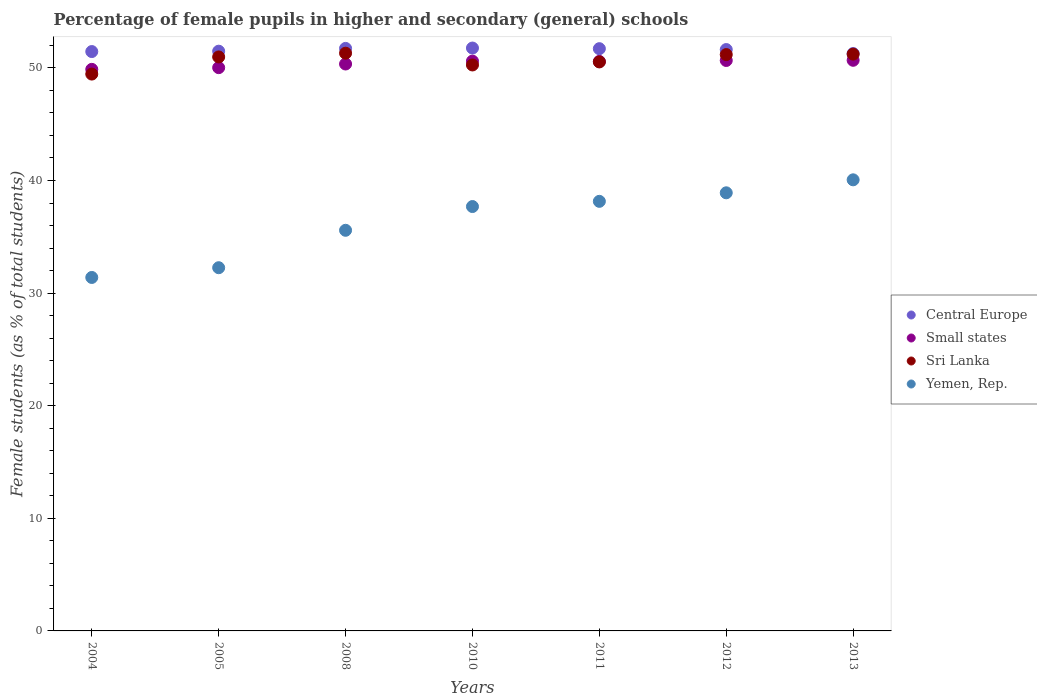What is the percentage of female pupils in higher and secondary schools in Yemen, Rep. in 2010?
Keep it short and to the point. 37.69. Across all years, what is the maximum percentage of female pupils in higher and secondary schools in Small states?
Keep it short and to the point. 50.67. Across all years, what is the minimum percentage of female pupils in higher and secondary schools in Sri Lanka?
Offer a terse response. 49.45. In which year was the percentage of female pupils in higher and secondary schools in Sri Lanka minimum?
Provide a succinct answer. 2004. What is the total percentage of female pupils in higher and secondary schools in Sri Lanka in the graph?
Keep it short and to the point. 354.91. What is the difference between the percentage of female pupils in higher and secondary schools in Sri Lanka in 2008 and that in 2012?
Make the answer very short. 0.12. What is the difference between the percentage of female pupils in higher and secondary schools in Sri Lanka in 2011 and the percentage of female pupils in higher and secondary schools in Central Europe in 2005?
Provide a succinct answer. -0.95. What is the average percentage of female pupils in higher and secondary schools in Central Europe per year?
Your answer should be compact. 51.57. In the year 2010, what is the difference between the percentage of female pupils in higher and secondary schools in Sri Lanka and percentage of female pupils in higher and secondary schools in Yemen, Rep.?
Ensure brevity in your answer.  12.57. What is the ratio of the percentage of female pupils in higher and secondary schools in Central Europe in 2010 to that in 2011?
Give a very brief answer. 1. Is the percentage of female pupils in higher and secondary schools in Small states in 2004 less than that in 2012?
Offer a terse response. Yes. Is the difference between the percentage of female pupils in higher and secondary schools in Sri Lanka in 2011 and 2012 greater than the difference between the percentage of female pupils in higher and secondary schools in Yemen, Rep. in 2011 and 2012?
Keep it short and to the point. Yes. What is the difference between the highest and the second highest percentage of female pupils in higher and secondary schools in Sri Lanka?
Your answer should be very brief. 0.08. What is the difference between the highest and the lowest percentage of female pupils in higher and secondary schools in Sri Lanka?
Offer a terse response. 1.85. In how many years, is the percentage of female pupils in higher and secondary schools in Central Europe greater than the average percentage of female pupils in higher and secondary schools in Central Europe taken over all years?
Offer a terse response. 4. Is it the case that in every year, the sum of the percentage of female pupils in higher and secondary schools in Small states and percentage of female pupils in higher and secondary schools in Central Europe  is greater than the sum of percentage of female pupils in higher and secondary schools in Sri Lanka and percentage of female pupils in higher and secondary schools in Yemen, Rep.?
Make the answer very short. Yes. Is the percentage of female pupils in higher and secondary schools in Yemen, Rep. strictly less than the percentage of female pupils in higher and secondary schools in Central Europe over the years?
Offer a very short reply. Yes. How many years are there in the graph?
Offer a terse response. 7. Does the graph contain any zero values?
Your answer should be very brief. No. Does the graph contain grids?
Offer a terse response. No. How many legend labels are there?
Provide a succinct answer. 4. What is the title of the graph?
Make the answer very short. Percentage of female pupils in higher and secondary (general) schools. What is the label or title of the Y-axis?
Offer a terse response. Female students (as % of total students). What is the Female students (as % of total students) in Central Europe in 2004?
Your answer should be very brief. 51.45. What is the Female students (as % of total students) of Small states in 2004?
Offer a very short reply. 49.87. What is the Female students (as % of total students) in Sri Lanka in 2004?
Offer a very short reply. 49.45. What is the Female students (as % of total students) of Yemen, Rep. in 2004?
Keep it short and to the point. 31.39. What is the Female students (as % of total students) in Central Europe in 2005?
Provide a short and direct response. 51.48. What is the Female students (as % of total students) in Small states in 2005?
Ensure brevity in your answer.  50.02. What is the Female students (as % of total students) of Sri Lanka in 2005?
Your answer should be compact. 50.97. What is the Female students (as % of total students) in Yemen, Rep. in 2005?
Your response must be concise. 32.25. What is the Female students (as % of total students) of Central Europe in 2008?
Your answer should be compact. 51.73. What is the Female students (as % of total students) in Small states in 2008?
Your answer should be very brief. 50.34. What is the Female students (as % of total students) of Sri Lanka in 2008?
Make the answer very short. 51.3. What is the Female students (as % of total students) of Yemen, Rep. in 2008?
Your response must be concise. 35.58. What is the Female students (as % of total students) of Central Europe in 2010?
Keep it short and to the point. 51.76. What is the Female students (as % of total students) in Small states in 2010?
Offer a very short reply. 50.6. What is the Female students (as % of total students) of Sri Lanka in 2010?
Ensure brevity in your answer.  50.26. What is the Female students (as % of total students) in Yemen, Rep. in 2010?
Offer a very short reply. 37.69. What is the Female students (as % of total students) of Central Europe in 2011?
Keep it short and to the point. 51.7. What is the Female students (as % of total students) of Small states in 2011?
Your answer should be compact. 50.57. What is the Female students (as % of total students) of Sri Lanka in 2011?
Provide a succinct answer. 50.53. What is the Female students (as % of total students) in Yemen, Rep. in 2011?
Your answer should be compact. 38.15. What is the Female students (as % of total students) of Central Europe in 2012?
Keep it short and to the point. 51.63. What is the Female students (as % of total students) of Small states in 2012?
Provide a short and direct response. 50.66. What is the Female students (as % of total students) in Sri Lanka in 2012?
Make the answer very short. 51.18. What is the Female students (as % of total students) in Yemen, Rep. in 2012?
Keep it short and to the point. 38.9. What is the Female students (as % of total students) of Central Europe in 2013?
Make the answer very short. 51.27. What is the Female students (as % of total students) in Small states in 2013?
Your answer should be very brief. 50.67. What is the Female students (as % of total students) of Sri Lanka in 2013?
Your answer should be very brief. 51.22. What is the Female students (as % of total students) in Yemen, Rep. in 2013?
Provide a short and direct response. 40.06. Across all years, what is the maximum Female students (as % of total students) of Central Europe?
Make the answer very short. 51.76. Across all years, what is the maximum Female students (as % of total students) in Small states?
Give a very brief answer. 50.67. Across all years, what is the maximum Female students (as % of total students) of Sri Lanka?
Keep it short and to the point. 51.3. Across all years, what is the maximum Female students (as % of total students) of Yemen, Rep.?
Offer a terse response. 40.06. Across all years, what is the minimum Female students (as % of total students) of Central Europe?
Your answer should be very brief. 51.27. Across all years, what is the minimum Female students (as % of total students) in Small states?
Offer a very short reply. 49.87. Across all years, what is the minimum Female students (as % of total students) in Sri Lanka?
Give a very brief answer. 49.45. Across all years, what is the minimum Female students (as % of total students) in Yemen, Rep.?
Ensure brevity in your answer.  31.39. What is the total Female students (as % of total students) in Central Europe in the graph?
Give a very brief answer. 361.02. What is the total Female students (as % of total students) in Small states in the graph?
Make the answer very short. 352.73. What is the total Female students (as % of total students) in Sri Lanka in the graph?
Keep it short and to the point. 354.91. What is the total Female students (as % of total students) of Yemen, Rep. in the graph?
Keep it short and to the point. 254.01. What is the difference between the Female students (as % of total students) of Central Europe in 2004 and that in 2005?
Ensure brevity in your answer.  -0.03. What is the difference between the Female students (as % of total students) of Small states in 2004 and that in 2005?
Your answer should be very brief. -0.15. What is the difference between the Female students (as % of total students) of Sri Lanka in 2004 and that in 2005?
Offer a terse response. -1.52. What is the difference between the Female students (as % of total students) of Yemen, Rep. in 2004 and that in 2005?
Provide a short and direct response. -0.86. What is the difference between the Female students (as % of total students) in Central Europe in 2004 and that in 2008?
Provide a short and direct response. -0.28. What is the difference between the Female students (as % of total students) in Small states in 2004 and that in 2008?
Your answer should be compact. -0.48. What is the difference between the Female students (as % of total students) of Sri Lanka in 2004 and that in 2008?
Your answer should be compact. -1.85. What is the difference between the Female students (as % of total students) in Yemen, Rep. in 2004 and that in 2008?
Your response must be concise. -4.19. What is the difference between the Female students (as % of total students) in Central Europe in 2004 and that in 2010?
Ensure brevity in your answer.  -0.31. What is the difference between the Female students (as % of total students) of Small states in 2004 and that in 2010?
Your response must be concise. -0.73. What is the difference between the Female students (as % of total students) of Sri Lanka in 2004 and that in 2010?
Give a very brief answer. -0.81. What is the difference between the Female students (as % of total students) in Yemen, Rep. in 2004 and that in 2010?
Your answer should be compact. -6.3. What is the difference between the Female students (as % of total students) in Central Europe in 2004 and that in 2011?
Make the answer very short. -0.26. What is the difference between the Female students (as % of total students) of Small states in 2004 and that in 2011?
Keep it short and to the point. -0.7. What is the difference between the Female students (as % of total students) in Sri Lanka in 2004 and that in 2011?
Provide a succinct answer. -1.08. What is the difference between the Female students (as % of total students) of Yemen, Rep. in 2004 and that in 2011?
Keep it short and to the point. -6.76. What is the difference between the Female students (as % of total students) in Central Europe in 2004 and that in 2012?
Ensure brevity in your answer.  -0.18. What is the difference between the Female students (as % of total students) in Small states in 2004 and that in 2012?
Keep it short and to the point. -0.79. What is the difference between the Female students (as % of total students) of Sri Lanka in 2004 and that in 2012?
Ensure brevity in your answer.  -1.73. What is the difference between the Female students (as % of total students) in Yemen, Rep. in 2004 and that in 2012?
Provide a succinct answer. -7.52. What is the difference between the Female students (as % of total students) of Central Europe in 2004 and that in 2013?
Provide a succinct answer. 0.18. What is the difference between the Female students (as % of total students) of Small states in 2004 and that in 2013?
Your response must be concise. -0.8. What is the difference between the Female students (as % of total students) of Sri Lanka in 2004 and that in 2013?
Provide a succinct answer. -1.77. What is the difference between the Female students (as % of total students) of Yemen, Rep. in 2004 and that in 2013?
Your answer should be compact. -8.67. What is the difference between the Female students (as % of total students) of Central Europe in 2005 and that in 2008?
Offer a terse response. -0.25. What is the difference between the Female students (as % of total students) of Small states in 2005 and that in 2008?
Provide a short and direct response. -0.32. What is the difference between the Female students (as % of total students) of Sri Lanka in 2005 and that in 2008?
Provide a short and direct response. -0.33. What is the difference between the Female students (as % of total students) in Yemen, Rep. in 2005 and that in 2008?
Offer a very short reply. -3.32. What is the difference between the Female students (as % of total students) in Central Europe in 2005 and that in 2010?
Your answer should be compact. -0.28. What is the difference between the Female students (as % of total students) of Small states in 2005 and that in 2010?
Give a very brief answer. -0.58. What is the difference between the Female students (as % of total students) of Sri Lanka in 2005 and that in 2010?
Make the answer very short. 0.71. What is the difference between the Female students (as % of total students) of Yemen, Rep. in 2005 and that in 2010?
Offer a terse response. -5.43. What is the difference between the Female students (as % of total students) in Central Europe in 2005 and that in 2011?
Your answer should be compact. -0.22. What is the difference between the Female students (as % of total students) in Small states in 2005 and that in 2011?
Your answer should be compact. -0.55. What is the difference between the Female students (as % of total students) of Sri Lanka in 2005 and that in 2011?
Your response must be concise. 0.44. What is the difference between the Female students (as % of total students) in Yemen, Rep. in 2005 and that in 2011?
Your response must be concise. -5.89. What is the difference between the Female students (as % of total students) of Central Europe in 2005 and that in 2012?
Offer a very short reply. -0.15. What is the difference between the Female students (as % of total students) in Small states in 2005 and that in 2012?
Your response must be concise. -0.64. What is the difference between the Female students (as % of total students) in Sri Lanka in 2005 and that in 2012?
Offer a terse response. -0.21. What is the difference between the Female students (as % of total students) of Yemen, Rep. in 2005 and that in 2012?
Your response must be concise. -6.65. What is the difference between the Female students (as % of total students) of Central Europe in 2005 and that in 2013?
Give a very brief answer. 0.21. What is the difference between the Female students (as % of total students) of Small states in 2005 and that in 2013?
Offer a very short reply. -0.65. What is the difference between the Female students (as % of total students) of Sri Lanka in 2005 and that in 2013?
Provide a short and direct response. -0.25. What is the difference between the Female students (as % of total students) of Yemen, Rep. in 2005 and that in 2013?
Provide a short and direct response. -7.8. What is the difference between the Female students (as % of total students) of Central Europe in 2008 and that in 2010?
Ensure brevity in your answer.  -0.03. What is the difference between the Female students (as % of total students) of Small states in 2008 and that in 2010?
Offer a terse response. -0.25. What is the difference between the Female students (as % of total students) in Sri Lanka in 2008 and that in 2010?
Your response must be concise. 1.05. What is the difference between the Female students (as % of total students) of Yemen, Rep. in 2008 and that in 2010?
Keep it short and to the point. -2.11. What is the difference between the Female students (as % of total students) of Central Europe in 2008 and that in 2011?
Provide a short and direct response. 0.02. What is the difference between the Female students (as % of total students) of Small states in 2008 and that in 2011?
Offer a terse response. -0.23. What is the difference between the Female students (as % of total students) in Sri Lanka in 2008 and that in 2011?
Offer a very short reply. 0.78. What is the difference between the Female students (as % of total students) of Yemen, Rep. in 2008 and that in 2011?
Your answer should be very brief. -2.57. What is the difference between the Female students (as % of total students) of Central Europe in 2008 and that in 2012?
Offer a terse response. 0.1. What is the difference between the Female students (as % of total students) of Small states in 2008 and that in 2012?
Your answer should be very brief. -0.31. What is the difference between the Female students (as % of total students) of Sri Lanka in 2008 and that in 2012?
Provide a short and direct response. 0.12. What is the difference between the Female students (as % of total students) of Yemen, Rep. in 2008 and that in 2012?
Ensure brevity in your answer.  -3.33. What is the difference between the Female students (as % of total students) of Central Europe in 2008 and that in 2013?
Provide a short and direct response. 0.46. What is the difference between the Female students (as % of total students) in Small states in 2008 and that in 2013?
Your answer should be compact. -0.33. What is the difference between the Female students (as % of total students) in Sri Lanka in 2008 and that in 2013?
Offer a very short reply. 0.08. What is the difference between the Female students (as % of total students) of Yemen, Rep. in 2008 and that in 2013?
Your response must be concise. -4.48. What is the difference between the Female students (as % of total students) of Central Europe in 2010 and that in 2011?
Keep it short and to the point. 0.06. What is the difference between the Female students (as % of total students) of Small states in 2010 and that in 2011?
Your answer should be very brief. 0.03. What is the difference between the Female students (as % of total students) in Sri Lanka in 2010 and that in 2011?
Offer a very short reply. -0.27. What is the difference between the Female students (as % of total students) of Yemen, Rep. in 2010 and that in 2011?
Your answer should be very brief. -0.46. What is the difference between the Female students (as % of total students) in Central Europe in 2010 and that in 2012?
Provide a succinct answer. 0.13. What is the difference between the Female students (as % of total students) of Small states in 2010 and that in 2012?
Offer a terse response. -0.06. What is the difference between the Female students (as % of total students) in Sri Lanka in 2010 and that in 2012?
Offer a terse response. -0.92. What is the difference between the Female students (as % of total students) of Yemen, Rep. in 2010 and that in 2012?
Offer a very short reply. -1.22. What is the difference between the Female students (as % of total students) in Central Europe in 2010 and that in 2013?
Offer a terse response. 0.49. What is the difference between the Female students (as % of total students) of Small states in 2010 and that in 2013?
Your answer should be very brief. -0.07. What is the difference between the Female students (as % of total students) in Sri Lanka in 2010 and that in 2013?
Provide a succinct answer. -0.96. What is the difference between the Female students (as % of total students) of Yemen, Rep. in 2010 and that in 2013?
Give a very brief answer. -2.37. What is the difference between the Female students (as % of total students) in Central Europe in 2011 and that in 2012?
Make the answer very short. 0.08. What is the difference between the Female students (as % of total students) in Small states in 2011 and that in 2012?
Offer a terse response. -0.08. What is the difference between the Female students (as % of total students) in Sri Lanka in 2011 and that in 2012?
Keep it short and to the point. -0.65. What is the difference between the Female students (as % of total students) of Yemen, Rep. in 2011 and that in 2012?
Your answer should be very brief. -0.76. What is the difference between the Female students (as % of total students) in Central Europe in 2011 and that in 2013?
Your response must be concise. 0.43. What is the difference between the Female students (as % of total students) in Small states in 2011 and that in 2013?
Keep it short and to the point. -0.1. What is the difference between the Female students (as % of total students) of Sri Lanka in 2011 and that in 2013?
Provide a succinct answer. -0.69. What is the difference between the Female students (as % of total students) in Yemen, Rep. in 2011 and that in 2013?
Offer a terse response. -1.91. What is the difference between the Female students (as % of total students) of Central Europe in 2012 and that in 2013?
Your answer should be compact. 0.35. What is the difference between the Female students (as % of total students) in Small states in 2012 and that in 2013?
Your answer should be compact. -0.02. What is the difference between the Female students (as % of total students) in Sri Lanka in 2012 and that in 2013?
Give a very brief answer. -0.04. What is the difference between the Female students (as % of total students) of Yemen, Rep. in 2012 and that in 2013?
Your response must be concise. -1.15. What is the difference between the Female students (as % of total students) in Central Europe in 2004 and the Female students (as % of total students) in Small states in 2005?
Your answer should be very brief. 1.43. What is the difference between the Female students (as % of total students) in Central Europe in 2004 and the Female students (as % of total students) in Sri Lanka in 2005?
Offer a terse response. 0.48. What is the difference between the Female students (as % of total students) of Central Europe in 2004 and the Female students (as % of total students) of Yemen, Rep. in 2005?
Offer a very short reply. 19.19. What is the difference between the Female students (as % of total students) in Small states in 2004 and the Female students (as % of total students) in Sri Lanka in 2005?
Offer a very short reply. -1.1. What is the difference between the Female students (as % of total students) of Small states in 2004 and the Female students (as % of total students) of Yemen, Rep. in 2005?
Give a very brief answer. 17.61. What is the difference between the Female students (as % of total students) of Sri Lanka in 2004 and the Female students (as % of total students) of Yemen, Rep. in 2005?
Your answer should be compact. 17.2. What is the difference between the Female students (as % of total students) of Central Europe in 2004 and the Female students (as % of total students) of Small states in 2008?
Provide a succinct answer. 1.1. What is the difference between the Female students (as % of total students) in Central Europe in 2004 and the Female students (as % of total students) in Sri Lanka in 2008?
Your answer should be compact. 0.14. What is the difference between the Female students (as % of total students) in Central Europe in 2004 and the Female students (as % of total students) in Yemen, Rep. in 2008?
Offer a very short reply. 15.87. What is the difference between the Female students (as % of total students) of Small states in 2004 and the Female students (as % of total students) of Sri Lanka in 2008?
Give a very brief answer. -1.44. What is the difference between the Female students (as % of total students) of Small states in 2004 and the Female students (as % of total students) of Yemen, Rep. in 2008?
Provide a succinct answer. 14.29. What is the difference between the Female students (as % of total students) in Sri Lanka in 2004 and the Female students (as % of total students) in Yemen, Rep. in 2008?
Give a very brief answer. 13.87. What is the difference between the Female students (as % of total students) of Central Europe in 2004 and the Female students (as % of total students) of Small states in 2010?
Keep it short and to the point. 0.85. What is the difference between the Female students (as % of total students) of Central Europe in 2004 and the Female students (as % of total students) of Sri Lanka in 2010?
Provide a succinct answer. 1.19. What is the difference between the Female students (as % of total students) in Central Europe in 2004 and the Female students (as % of total students) in Yemen, Rep. in 2010?
Provide a succinct answer. 13.76. What is the difference between the Female students (as % of total students) in Small states in 2004 and the Female students (as % of total students) in Sri Lanka in 2010?
Your answer should be very brief. -0.39. What is the difference between the Female students (as % of total students) of Small states in 2004 and the Female students (as % of total students) of Yemen, Rep. in 2010?
Make the answer very short. 12.18. What is the difference between the Female students (as % of total students) of Sri Lanka in 2004 and the Female students (as % of total students) of Yemen, Rep. in 2010?
Provide a succinct answer. 11.76. What is the difference between the Female students (as % of total students) in Central Europe in 2004 and the Female students (as % of total students) in Small states in 2011?
Offer a very short reply. 0.88. What is the difference between the Female students (as % of total students) in Central Europe in 2004 and the Female students (as % of total students) in Sri Lanka in 2011?
Offer a very short reply. 0.92. What is the difference between the Female students (as % of total students) of Central Europe in 2004 and the Female students (as % of total students) of Yemen, Rep. in 2011?
Your answer should be very brief. 13.3. What is the difference between the Female students (as % of total students) in Small states in 2004 and the Female students (as % of total students) in Sri Lanka in 2011?
Give a very brief answer. -0.66. What is the difference between the Female students (as % of total students) of Small states in 2004 and the Female students (as % of total students) of Yemen, Rep. in 2011?
Provide a succinct answer. 11.72. What is the difference between the Female students (as % of total students) in Sri Lanka in 2004 and the Female students (as % of total students) in Yemen, Rep. in 2011?
Provide a succinct answer. 11.3. What is the difference between the Female students (as % of total students) in Central Europe in 2004 and the Female students (as % of total students) in Small states in 2012?
Provide a short and direct response. 0.79. What is the difference between the Female students (as % of total students) of Central Europe in 2004 and the Female students (as % of total students) of Sri Lanka in 2012?
Keep it short and to the point. 0.27. What is the difference between the Female students (as % of total students) in Central Europe in 2004 and the Female students (as % of total students) in Yemen, Rep. in 2012?
Ensure brevity in your answer.  12.54. What is the difference between the Female students (as % of total students) in Small states in 2004 and the Female students (as % of total students) in Sri Lanka in 2012?
Provide a short and direct response. -1.31. What is the difference between the Female students (as % of total students) of Small states in 2004 and the Female students (as % of total students) of Yemen, Rep. in 2012?
Your answer should be compact. 10.96. What is the difference between the Female students (as % of total students) of Sri Lanka in 2004 and the Female students (as % of total students) of Yemen, Rep. in 2012?
Give a very brief answer. 10.54. What is the difference between the Female students (as % of total students) of Central Europe in 2004 and the Female students (as % of total students) of Small states in 2013?
Make the answer very short. 0.78. What is the difference between the Female students (as % of total students) of Central Europe in 2004 and the Female students (as % of total students) of Sri Lanka in 2013?
Provide a succinct answer. 0.23. What is the difference between the Female students (as % of total students) of Central Europe in 2004 and the Female students (as % of total students) of Yemen, Rep. in 2013?
Your answer should be compact. 11.39. What is the difference between the Female students (as % of total students) of Small states in 2004 and the Female students (as % of total students) of Sri Lanka in 2013?
Offer a very short reply. -1.35. What is the difference between the Female students (as % of total students) in Small states in 2004 and the Female students (as % of total students) in Yemen, Rep. in 2013?
Make the answer very short. 9.81. What is the difference between the Female students (as % of total students) in Sri Lanka in 2004 and the Female students (as % of total students) in Yemen, Rep. in 2013?
Your answer should be very brief. 9.39. What is the difference between the Female students (as % of total students) in Central Europe in 2005 and the Female students (as % of total students) in Small states in 2008?
Your answer should be compact. 1.14. What is the difference between the Female students (as % of total students) of Central Europe in 2005 and the Female students (as % of total students) of Sri Lanka in 2008?
Offer a very short reply. 0.18. What is the difference between the Female students (as % of total students) in Central Europe in 2005 and the Female students (as % of total students) in Yemen, Rep. in 2008?
Ensure brevity in your answer.  15.9. What is the difference between the Female students (as % of total students) in Small states in 2005 and the Female students (as % of total students) in Sri Lanka in 2008?
Keep it short and to the point. -1.28. What is the difference between the Female students (as % of total students) in Small states in 2005 and the Female students (as % of total students) in Yemen, Rep. in 2008?
Make the answer very short. 14.44. What is the difference between the Female students (as % of total students) of Sri Lanka in 2005 and the Female students (as % of total students) of Yemen, Rep. in 2008?
Provide a succinct answer. 15.39. What is the difference between the Female students (as % of total students) in Central Europe in 2005 and the Female students (as % of total students) in Small states in 2010?
Your answer should be compact. 0.88. What is the difference between the Female students (as % of total students) of Central Europe in 2005 and the Female students (as % of total students) of Sri Lanka in 2010?
Keep it short and to the point. 1.22. What is the difference between the Female students (as % of total students) of Central Europe in 2005 and the Female students (as % of total students) of Yemen, Rep. in 2010?
Give a very brief answer. 13.79. What is the difference between the Female students (as % of total students) in Small states in 2005 and the Female students (as % of total students) in Sri Lanka in 2010?
Your answer should be compact. -0.24. What is the difference between the Female students (as % of total students) of Small states in 2005 and the Female students (as % of total students) of Yemen, Rep. in 2010?
Offer a very short reply. 12.33. What is the difference between the Female students (as % of total students) of Sri Lanka in 2005 and the Female students (as % of total students) of Yemen, Rep. in 2010?
Offer a very short reply. 13.28. What is the difference between the Female students (as % of total students) of Central Europe in 2005 and the Female students (as % of total students) of Small states in 2011?
Give a very brief answer. 0.91. What is the difference between the Female students (as % of total students) in Central Europe in 2005 and the Female students (as % of total students) in Sri Lanka in 2011?
Your answer should be very brief. 0.95. What is the difference between the Female students (as % of total students) of Central Europe in 2005 and the Female students (as % of total students) of Yemen, Rep. in 2011?
Give a very brief answer. 13.33. What is the difference between the Female students (as % of total students) of Small states in 2005 and the Female students (as % of total students) of Sri Lanka in 2011?
Keep it short and to the point. -0.51. What is the difference between the Female students (as % of total students) of Small states in 2005 and the Female students (as % of total students) of Yemen, Rep. in 2011?
Your answer should be compact. 11.87. What is the difference between the Female students (as % of total students) in Sri Lanka in 2005 and the Female students (as % of total students) in Yemen, Rep. in 2011?
Your answer should be very brief. 12.82. What is the difference between the Female students (as % of total students) in Central Europe in 2005 and the Female students (as % of total students) in Small states in 2012?
Provide a succinct answer. 0.82. What is the difference between the Female students (as % of total students) in Central Europe in 2005 and the Female students (as % of total students) in Sri Lanka in 2012?
Your response must be concise. 0.3. What is the difference between the Female students (as % of total students) of Central Europe in 2005 and the Female students (as % of total students) of Yemen, Rep. in 2012?
Offer a terse response. 12.58. What is the difference between the Female students (as % of total students) in Small states in 2005 and the Female students (as % of total students) in Sri Lanka in 2012?
Make the answer very short. -1.16. What is the difference between the Female students (as % of total students) of Small states in 2005 and the Female students (as % of total students) of Yemen, Rep. in 2012?
Make the answer very short. 11.11. What is the difference between the Female students (as % of total students) in Sri Lanka in 2005 and the Female students (as % of total students) in Yemen, Rep. in 2012?
Provide a succinct answer. 12.07. What is the difference between the Female students (as % of total students) in Central Europe in 2005 and the Female students (as % of total students) in Small states in 2013?
Offer a terse response. 0.81. What is the difference between the Female students (as % of total students) in Central Europe in 2005 and the Female students (as % of total students) in Sri Lanka in 2013?
Offer a very short reply. 0.26. What is the difference between the Female students (as % of total students) of Central Europe in 2005 and the Female students (as % of total students) of Yemen, Rep. in 2013?
Your response must be concise. 11.42. What is the difference between the Female students (as % of total students) in Small states in 2005 and the Female students (as % of total students) in Sri Lanka in 2013?
Make the answer very short. -1.2. What is the difference between the Female students (as % of total students) of Small states in 2005 and the Female students (as % of total students) of Yemen, Rep. in 2013?
Ensure brevity in your answer.  9.96. What is the difference between the Female students (as % of total students) of Sri Lanka in 2005 and the Female students (as % of total students) of Yemen, Rep. in 2013?
Your response must be concise. 10.91. What is the difference between the Female students (as % of total students) in Central Europe in 2008 and the Female students (as % of total students) in Small states in 2010?
Your answer should be very brief. 1.13. What is the difference between the Female students (as % of total students) in Central Europe in 2008 and the Female students (as % of total students) in Sri Lanka in 2010?
Give a very brief answer. 1.47. What is the difference between the Female students (as % of total students) of Central Europe in 2008 and the Female students (as % of total students) of Yemen, Rep. in 2010?
Make the answer very short. 14.04. What is the difference between the Female students (as % of total students) in Small states in 2008 and the Female students (as % of total students) in Sri Lanka in 2010?
Provide a short and direct response. 0.09. What is the difference between the Female students (as % of total students) in Small states in 2008 and the Female students (as % of total students) in Yemen, Rep. in 2010?
Your answer should be very brief. 12.66. What is the difference between the Female students (as % of total students) in Sri Lanka in 2008 and the Female students (as % of total students) in Yemen, Rep. in 2010?
Offer a terse response. 13.62. What is the difference between the Female students (as % of total students) in Central Europe in 2008 and the Female students (as % of total students) in Small states in 2011?
Your answer should be very brief. 1.16. What is the difference between the Female students (as % of total students) of Central Europe in 2008 and the Female students (as % of total students) of Sri Lanka in 2011?
Make the answer very short. 1.2. What is the difference between the Female students (as % of total students) of Central Europe in 2008 and the Female students (as % of total students) of Yemen, Rep. in 2011?
Offer a terse response. 13.58. What is the difference between the Female students (as % of total students) in Small states in 2008 and the Female students (as % of total students) in Sri Lanka in 2011?
Keep it short and to the point. -0.18. What is the difference between the Female students (as % of total students) in Small states in 2008 and the Female students (as % of total students) in Yemen, Rep. in 2011?
Offer a very short reply. 12.2. What is the difference between the Female students (as % of total students) in Sri Lanka in 2008 and the Female students (as % of total students) in Yemen, Rep. in 2011?
Keep it short and to the point. 13.16. What is the difference between the Female students (as % of total students) in Central Europe in 2008 and the Female students (as % of total students) in Small states in 2012?
Make the answer very short. 1.07. What is the difference between the Female students (as % of total students) in Central Europe in 2008 and the Female students (as % of total students) in Sri Lanka in 2012?
Provide a succinct answer. 0.55. What is the difference between the Female students (as % of total students) in Central Europe in 2008 and the Female students (as % of total students) in Yemen, Rep. in 2012?
Offer a terse response. 12.82. What is the difference between the Female students (as % of total students) in Small states in 2008 and the Female students (as % of total students) in Sri Lanka in 2012?
Your response must be concise. -0.84. What is the difference between the Female students (as % of total students) in Small states in 2008 and the Female students (as % of total students) in Yemen, Rep. in 2012?
Give a very brief answer. 11.44. What is the difference between the Female students (as % of total students) of Sri Lanka in 2008 and the Female students (as % of total students) of Yemen, Rep. in 2012?
Ensure brevity in your answer.  12.4. What is the difference between the Female students (as % of total students) in Central Europe in 2008 and the Female students (as % of total students) in Small states in 2013?
Your answer should be compact. 1.06. What is the difference between the Female students (as % of total students) of Central Europe in 2008 and the Female students (as % of total students) of Sri Lanka in 2013?
Your response must be concise. 0.51. What is the difference between the Female students (as % of total students) of Central Europe in 2008 and the Female students (as % of total students) of Yemen, Rep. in 2013?
Provide a succinct answer. 11.67. What is the difference between the Female students (as % of total students) of Small states in 2008 and the Female students (as % of total students) of Sri Lanka in 2013?
Ensure brevity in your answer.  -0.88. What is the difference between the Female students (as % of total students) of Small states in 2008 and the Female students (as % of total students) of Yemen, Rep. in 2013?
Your answer should be compact. 10.29. What is the difference between the Female students (as % of total students) of Sri Lanka in 2008 and the Female students (as % of total students) of Yemen, Rep. in 2013?
Provide a short and direct response. 11.25. What is the difference between the Female students (as % of total students) in Central Europe in 2010 and the Female students (as % of total students) in Small states in 2011?
Provide a short and direct response. 1.19. What is the difference between the Female students (as % of total students) in Central Europe in 2010 and the Female students (as % of total students) in Sri Lanka in 2011?
Make the answer very short. 1.23. What is the difference between the Female students (as % of total students) in Central Europe in 2010 and the Female students (as % of total students) in Yemen, Rep. in 2011?
Ensure brevity in your answer.  13.61. What is the difference between the Female students (as % of total students) of Small states in 2010 and the Female students (as % of total students) of Sri Lanka in 2011?
Keep it short and to the point. 0.07. What is the difference between the Female students (as % of total students) of Small states in 2010 and the Female students (as % of total students) of Yemen, Rep. in 2011?
Your answer should be compact. 12.45. What is the difference between the Female students (as % of total students) of Sri Lanka in 2010 and the Female students (as % of total students) of Yemen, Rep. in 2011?
Provide a short and direct response. 12.11. What is the difference between the Female students (as % of total students) in Central Europe in 2010 and the Female students (as % of total students) in Small states in 2012?
Offer a very short reply. 1.1. What is the difference between the Female students (as % of total students) of Central Europe in 2010 and the Female students (as % of total students) of Sri Lanka in 2012?
Your answer should be compact. 0.58. What is the difference between the Female students (as % of total students) of Central Europe in 2010 and the Female students (as % of total students) of Yemen, Rep. in 2012?
Keep it short and to the point. 12.86. What is the difference between the Female students (as % of total students) in Small states in 2010 and the Female students (as % of total students) in Sri Lanka in 2012?
Keep it short and to the point. -0.58. What is the difference between the Female students (as % of total students) of Small states in 2010 and the Female students (as % of total students) of Yemen, Rep. in 2012?
Ensure brevity in your answer.  11.69. What is the difference between the Female students (as % of total students) in Sri Lanka in 2010 and the Female students (as % of total students) in Yemen, Rep. in 2012?
Give a very brief answer. 11.35. What is the difference between the Female students (as % of total students) of Central Europe in 2010 and the Female students (as % of total students) of Small states in 2013?
Offer a terse response. 1.09. What is the difference between the Female students (as % of total students) in Central Europe in 2010 and the Female students (as % of total students) in Sri Lanka in 2013?
Offer a very short reply. 0.54. What is the difference between the Female students (as % of total students) of Central Europe in 2010 and the Female students (as % of total students) of Yemen, Rep. in 2013?
Make the answer very short. 11.7. What is the difference between the Female students (as % of total students) of Small states in 2010 and the Female students (as % of total students) of Sri Lanka in 2013?
Offer a very short reply. -0.62. What is the difference between the Female students (as % of total students) of Small states in 2010 and the Female students (as % of total students) of Yemen, Rep. in 2013?
Ensure brevity in your answer.  10.54. What is the difference between the Female students (as % of total students) in Central Europe in 2011 and the Female students (as % of total students) in Small states in 2012?
Your answer should be very brief. 1.05. What is the difference between the Female students (as % of total students) of Central Europe in 2011 and the Female students (as % of total students) of Sri Lanka in 2012?
Give a very brief answer. 0.52. What is the difference between the Female students (as % of total students) of Central Europe in 2011 and the Female students (as % of total students) of Yemen, Rep. in 2012?
Your response must be concise. 12.8. What is the difference between the Female students (as % of total students) in Small states in 2011 and the Female students (as % of total students) in Sri Lanka in 2012?
Give a very brief answer. -0.61. What is the difference between the Female students (as % of total students) in Small states in 2011 and the Female students (as % of total students) in Yemen, Rep. in 2012?
Your answer should be compact. 11.67. What is the difference between the Female students (as % of total students) in Sri Lanka in 2011 and the Female students (as % of total students) in Yemen, Rep. in 2012?
Keep it short and to the point. 11.62. What is the difference between the Female students (as % of total students) in Central Europe in 2011 and the Female students (as % of total students) in Small states in 2013?
Keep it short and to the point. 1.03. What is the difference between the Female students (as % of total students) of Central Europe in 2011 and the Female students (as % of total students) of Sri Lanka in 2013?
Ensure brevity in your answer.  0.48. What is the difference between the Female students (as % of total students) in Central Europe in 2011 and the Female students (as % of total students) in Yemen, Rep. in 2013?
Provide a short and direct response. 11.65. What is the difference between the Female students (as % of total students) in Small states in 2011 and the Female students (as % of total students) in Sri Lanka in 2013?
Give a very brief answer. -0.65. What is the difference between the Female students (as % of total students) in Small states in 2011 and the Female students (as % of total students) in Yemen, Rep. in 2013?
Provide a short and direct response. 10.51. What is the difference between the Female students (as % of total students) of Sri Lanka in 2011 and the Female students (as % of total students) of Yemen, Rep. in 2013?
Provide a short and direct response. 10.47. What is the difference between the Female students (as % of total students) in Central Europe in 2012 and the Female students (as % of total students) in Small states in 2013?
Offer a terse response. 0.95. What is the difference between the Female students (as % of total students) of Central Europe in 2012 and the Female students (as % of total students) of Sri Lanka in 2013?
Give a very brief answer. 0.41. What is the difference between the Female students (as % of total students) in Central Europe in 2012 and the Female students (as % of total students) in Yemen, Rep. in 2013?
Your response must be concise. 11.57. What is the difference between the Female students (as % of total students) in Small states in 2012 and the Female students (as % of total students) in Sri Lanka in 2013?
Provide a succinct answer. -0.56. What is the difference between the Female students (as % of total students) of Small states in 2012 and the Female students (as % of total students) of Yemen, Rep. in 2013?
Offer a very short reply. 10.6. What is the difference between the Female students (as % of total students) in Sri Lanka in 2012 and the Female students (as % of total students) in Yemen, Rep. in 2013?
Provide a short and direct response. 11.12. What is the average Female students (as % of total students) in Central Europe per year?
Offer a terse response. 51.57. What is the average Female students (as % of total students) of Small states per year?
Provide a succinct answer. 50.39. What is the average Female students (as % of total students) of Sri Lanka per year?
Your answer should be very brief. 50.7. What is the average Female students (as % of total students) of Yemen, Rep. per year?
Offer a very short reply. 36.29. In the year 2004, what is the difference between the Female students (as % of total students) in Central Europe and Female students (as % of total students) in Small states?
Offer a terse response. 1.58. In the year 2004, what is the difference between the Female students (as % of total students) in Central Europe and Female students (as % of total students) in Sri Lanka?
Make the answer very short. 2. In the year 2004, what is the difference between the Female students (as % of total students) of Central Europe and Female students (as % of total students) of Yemen, Rep.?
Your answer should be compact. 20.06. In the year 2004, what is the difference between the Female students (as % of total students) of Small states and Female students (as % of total students) of Sri Lanka?
Your answer should be compact. 0.42. In the year 2004, what is the difference between the Female students (as % of total students) in Small states and Female students (as % of total students) in Yemen, Rep.?
Your answer should be very brief. 18.48. In the year 2004, what is the difference between the Female students (as % of total students) in Sri Lanka and Female students (as % of total students) in Yemen, Rep.?
Your answer should be compact. 18.06. In the year 2005, what is the difference between the Female students (as % of total students) of Central Europe and Female students (as % of total students) of Small states?
Make the answer very short. 1.46. In the year 2005, what is the difference between the Female students (as % of total students) in Central Europe and Female students (as % of total students) in Sri Lanka?
Offer a very short reply. 0.51. In the year 2005, what is the difference between the Female students (as % of total students) of Central Europe and Female students (as % of total students) of Yemen, Rep.?
Your answer should be very brief. 19.23. In the year 2005, what is the difference between the Female students (as % of total students) of Small states and Female students (as % of total students) of Sri Lanka?
Provide a short and direct response. -0.95. In the year 2005, what is the difference between the Female students (as % of total students) of Small states and Female students (as % of total students) of Yemen, Rep.?
Your answer should be very brief. 17.77. In the year 2005, what is the difference between the Female students (as % of total students) in Sri Lanka and Female students (as % of total students) in Yemen, Rep.?
Ensure brevity in your answer.  18.72. In the year 2008, what is the difference between the Female students (as % of total students) in Central Europe and Female students (as % of total students) in Small states?
Ensure brevity in your answer.  1.39. In the year 2008, what is the difference between the Female students (as % of total students) in Central Europe and Female students (as % of total students) in Sri Lanka?
Ensure brevity in your answer.  0.42. In the year 2008, what is the difference between the Female students (as % of total students) of Central Europe and Female students (as % of total students) of Yemen, Rep.?
Make the answer very short. 16.15. In the year 2008, what is the difference between the Female students (as % of total students) of Small states and Female students (as % of total students) of Sri Lanka?
Provide a short and direct response. -0.96. In the year 2008, what is the difference between the Female students (as % of total students) of Small states and Female students (as % of total students) of Yemen, Rep.?
Provide a succinct answer. 14.77. In the year 2008, what is the difference between the Female students (as % of total students) in Sri Lanka and Female students (as % of total students) in Yemen, Rep.?
Give a very brief answer. 15.73. In the year 2010, what is the difference between the Female students (as % of total students) of Central Europe and Female students (as % of total students) of Small states?
Offer a very short reply. 1.16. In the year 2010, what is the difference between the Female students (as % of total students) of Central Europe and Female students (as % of total students) of Sri Lanka?
Keep it short and to the point. 1.5. In the year 2010, what is the difference between the Female students (as % of total students) in Central Europe and Female students (as % of total students) in Yemen, Rep.?
Your answer should be compact. 14.07. In the year 2010, what is the difference between the Female students (as % of total students) of Small states and Female students (as % of total students) of Sri Lanka?
Keep it short and to the point. 0.34. In the year 2010, what is the difference between the Female students (as % of total students) of Small states and Female students (as % of total students) of Yemen, Rep.?
Offer a very short reply. 12.91. In the year 2010, what is the difference between the Female students (as % of total students) in Sri Lanka and Female students (as % of total students) in Yemen, Rep.?
Offer a terse response. 12.57. In the year 2011, what is the difference between the Female students (as % of total students) in Central Europe and Female students (as % of total students) in Small states?
Your answer should be compact. 1.13. In the year 2011, what is the difference between the Female students (as % of total students) in Central Europe and Female students (as % of total students) in Sri Lanka?
Your response must be concise. 1.18. In the year 2011, what is the difference between the Female students (as % of total students) of Central Europe and Female students (as % of total students) of Yemen, Rep.?
Provide a succinct answer. 13.56. In the year 2011, what is the difference between the Female students (as % of total students) in Small states and Female students (as % of total students) in Sri Lanka?
Provide a short and direct response. 0.04. In the year 2011, what is the difference between the Female students (as % of total students) of Small states and Female students (as % of total students) of Yemen, Rep.?
Offer a very short reply. 12.43. In the year 2011, what is the difference between the Female students (as % of total students) in Sri Lanka and Female students (as % of total students) in Yemen, Rep.?
Provide a succinct answer. 12.38. In the year 2012, what is the difference between the Female students (as % of total students) of Central Europe and Female students (as % of total students) of Small states?
Ensure brevity in your answer.  0.97. In the year 2012, what is the difference between the Female students (as % of total students) of Central Europe and Female students (as % of total students) of Sri Lanka?
Provide a short and direct response. 0.45. In the year 2012, what is the difference between the Female students (as % of total students) of Central Europe and Female students (as % of total students) of Yemen, Rep.?
Your response must be concise. 12.72. In the year 2012, what is the difference between the Female students (as % of total students) of Small states and Female students (as % of total students) of Sri Lanka?
Provide a succinct answer. -0.52. In the year 2012, what is the difference between the Female students (as % of total students) of Small states and Female students (as % of total students) of Yemen, Rep.?
Provide a succinct answer. 11.75. In the year 2012, what is the difference between the Female students (as % of total students) of Sri Lanka and Female students (as % of total students) of Yemen, Rep.?
Offer a very short reply. 12.28. In the year 2013, what is the difference between the Female students (as % of total students) of Central Europe and Female students (as % of total students) of Small states?
Offer a terse response. 0.6. In the year 2013, what is the difference between the Female students (as % of total students) of Central Europe and Female students (as % of total students) of Sri Lanka?
Offer a terse response. 0.05. In the year 2013, what is the difference between the Female students (as % of total students) of Central Europe and Female students (as % of total students) of Yemen, Rep.?
Your response must be concise. 11.21. In the year 2013, what is the difference between the Female students (as % of total students) in Small states and Female students (as % of total students) in Sri Lanka?
Give a very brief answer. -0.55. In the year 2013, what is the difference between the Female students (as % of total students) in Small states and Female students (as % of total students) in Yemen, Rep.?
Your response must be concise. 10.61. In the year 2013, what is the difference between the Female students (as % of total students) in Sri Lanka and Female students (as % of total students) in Yemen, Rep.?
Keep it short and to the point. 11.16. What is the ratio of the Female students (as % of total students) in Sri Lanka in 2004 to that in 2005?
Keep it short and to the point. 0.97. What is the ratio of the Female students (as % of total students) in Yemen, Rep. in 2004 to that in 2005?
Your answer should be compact. 0.97. What is the ratio of the Female students (as % of total students) of Small states in 2004 to that in 2008?
Make the answer very short. 0.99. What is the ratio of the Female students (as % of total students) of Sri Lanka in 2004 to that in 2008?
Provide a succinct answer. 0.96. What is the ratio of the Female students (as % of total students) in Yemen, Rep. in 2004 to that in 2008?
Keep it short and to the point. 0.88. What is the ratio of the Female students (as % of total students) in Central Europe in 2004 to that in 2010?
Give a very brief answer. 0.99. What is the ratio of the Female students (as % of total students) of Small states in 2004 to that in 2010?
Ensure brevity in your answer.  0.99. What is the ratio of the Female students (as % of total students) of Sri Lanka in 2004 to that in 2010?
Provide a succinct answer. 0.98. What is the ratio of the Female students (as % of total students) of Yemen, Rep. in 2004 to that in 2010?
Your response must be concise. 0.83. What is the ratio of the Female students (as % of total students) of Small states in 2004 to that in 2011?
Your answer should be very brief. 0.99. What is the ratio of the Female students (as % of total students) of Sri Lanka in 2004 to that in 2011?
Offer a terse response. 0.98. What is the ratio of the Female students (as % of total students) of Yemen, Rep. in 2004 to that in 2011?
Your answer should be compact. 0.82. What is the ratio of the Female students (as % of total students) in Central Europe in 2004 to that in 2012?
Your answer should be compact. 1. What is the ratio of the Female students (as % of total students) of Small states in 2004 to that in 2012?
Your answer should be very brief. 0.98. What is the ratio of the Female students (as % of total students) in Sri Lanka in 2004 to that in 2012?
Make the answer very short. 0.97. What is the ratio of the Female students (as % of total students) in Yemen, Rep. in 2004 to that in 2012?
Provide a succinct answer. 0.81. What is the ratio of the Female students (as % of total students) in Central Europe in 2004 to that in 2013?
Ensure brevity in your answer.  1. What is the ratio of the Female students (as % of total students) in Small states in 2004 to that in 2013?
Provide a short and direct response. 0.98. What is the ratio of the Female students (as % of total students) in Sri Lanka in 2004 to that in 2013?
Give a very brief answer. 0.97. What is the ratio of the Female students (as % of total students) of Yemen, Rep. in 2004 to that in 2013?
Provide a short and direct response. 0.78. What is the ratio of the Female students (as % of total students) of Small states in 2005 to that in 2008?
Your response must be concise. 0.99. What is the ratio of the Female students (as % of total students) in Yemen, Rep. in 2005 to that in 2008?
Your response must be concise. 0.91. What is the ratio of the Female students (as % of total students) in Central Europe in 2005 to that in 2010?
Make the answer very short. 0.99. What is the ratio of the Female students (as % of total students) in Sri Lanka in 2005 to that in 2010?
Provide a short and direct response. 1.01. What is the ratio of the Female students (as % of total students) of Yemen, Rep. in 2005 to that in 2010?
Your answer should be very brief. 0.86. What is the ratio of the Female students (as % of total students) in Sri Lanka in 2005 to that in 2011?
Offer a very short reply. 1.01. What is the ratio of the Female students (as % of total students) of Yemen, Rep. in 2005 to that in 2011?
Offer a terse response. 0.85. What is the ratio of the Female students (as % of total students) in Central Europe in 2005 to that in 2012?
Offer a terse response. 1. What is the ratio of the Female students (as % of total students) of Small states in 2005 to that in 2012?
Keep it short and to the point. 0.99. What is the ratio of the Female students (as % of total students) of Sri Lanka in 2005 to that in 2012?
Make the answer very short. 1. What is the ratio of the Female students (as % of total students) of Yemen, Rep. in 2005 to that in 2012?
Your response must be concise. 0.83. What is the ratio of the Female students (as % of total students) of Small states in 2005 to that in 2013?
Keep it short and to the point. 0.99. What is the ratio of the Female students (as % of total students) in Yemen, Rep. in 2005 to that in 2013?
Give a very brief answer. 0.81. What is the ratio of the Female students (as % of total students) of Small states in 2008 to that in 2010?
Provide a short and direct response. 0.99. What is the ratio of the Female students (as % of total students) of Sri Lanka in 2008 to that in 2010?
Your response must be concise. 1.02. What is the ratio of the Female students (as % of total students) in Yemen, Rep. in 2008 to that in 2010?
Provide a short and direct response. 0.94. What is the ratio of the Female students (as % of total students) of Central Europe in 2008 to that in 2011?
Your answer should be very brief. 1. What is the ratio of the Female students (as % of total students) in Small states in 2008 to that in 2011?
Keep it short and to the point. 1. What is the ratio of the Female students (as % of total students) in Sri Lanka in 2008 to that in 2011?
Give a very brief answer. 1.02. What is the ratio of the Female students (as % of total students) in Yemen, Rep. in 2008 to that in 2011?
Offer a very short reply. 0.93. What is the ratio of the Female students (as % of total students) of Central Europe in 2008 to that in 2012?
Give a very brief answer. 1. What is the ratio of the Female students (as % of total students) of Sri Lanka in 2008 to that in 2012?
Give a very brief answer. 1. What is the ratio of the Female students (as % of total students) of Yemen, Rep. in 2008 to that in 2012?
Offer a terse response. 0.91. What is the ratio of the Female students (as % of total students) of Central Europe in 2008 to that in 2013?
Keep it short and to the point. 1.01. What is the ratio of the Female students (as % of total students) in Small states in 2008 to that in 2013?
Your response must be concise. 0.99. What is the ratio of the Female students (as % of total students) of Sri Lanka in 2008 to that in 2013?
Offer a very short reply. 1. What is the ratio of the Female students (as % of total students) in Yemen, Rep. in 2008 to that in 2013?
Offer a terse response. 0.89. What is the ratio of the Female students (as % of total students) in Central Europe in 2010 to that in 2011?
Your response must be concise. 1. What is the ratio of the Female students (as % of total students) of Small states in 2010 to that in 2011?
Your answer should be very brief. 1. What is the ratio of the Female students (as % of total students) in Yemen, Rep. in 2010 to that in 2011?
Provide a short and direct response. 0.99. What is the ratio of the Female students (as % of total students) in Yemen, Rep. in 2010 to that in 2012?
Give a very brief answer. 0.97. What is the ratio of the Female students (as % of total students) in Central Europe in 2010 to that in 2013?
Ensure brevity in your answer.  1.01. What is the ratio of the Female students (as % of total students) of Sri Lanka in 2010 to that in 2013?
Your response must be concise. 0.98. What is the ratio of the Female students (as % of total students) of Yemen, Rep. in 2010 to that in 2013?
Provide a short and direct response. 0.94. What is the ratio of the Female students (as % of total students) in Central Europe in 2011 to that in 2012?
Your answer should be very brief. 1. What is the ratio of the Female students (as % of total students) of Sri Lanka in 2011 to that in 2012?
Ensure brevity in your answer.  0.99. What is the ratio of the Female students (as % of total students) in Yemen, Rep. in 2011 to that in 2012?
Make the answer very short. 0.98. What is the ratio of the Female students (as % of total students) in Central Europe in 2011 to that in 2013?
Provide a short and direct response. 1.01. What is the ratio of the Female students (as % of total students) in Sri Lanka in 2011 to that in 2013?
Keep it short and to the point. 0.99. What is the ratio of the Female students (as % of total students) of Yemen, Rep. in 2011 to that in 2013?
Give a very brief answer. 0.95. What is the ratio of the Female students (as % of total students) in Sri Lanka in 2012 to that in 2013?
Give a very brief answer. 1. What is the ratio of the Female students (as % of total students) of Yemen, Rep. in 2012 to that in 2013?
Your response must be concise. 0.97. What is the difference between the highest and the second highest Female students (as % of total students) of Central Europe?
Your response must be concise. 0.03. What is the difference between the highest and the second highest Female students (as % of total students) in Small states?
Make the answer very short. 0.02. What is the difference between the highest and the second highest Female students (as % of total students) in Sri Lanka?
Your answer should be very brief. 0.08. What is the difference between the highest and the second highest Female students (as % of total students) in Yemen, Rep.?
Your answer should be very brief. 1.15. What is the difference between the highest and the lowest Female students (as % of total students) of Central Europe?
Offer a terse response. 0.49. What is the difference between the highest and the lowest Female students (as % of total students) in Small states?
Provide a succinct answer. 0.8. What is the difference between the highest and the lowest Female students (as % of total students) of Sri Lanka?
Keep it short and to the point. 1.85. What is the difference between the highest and the lowest Female students (as % of total students) in Yemen, Rep.?
Make the answer very short. 8.67. 